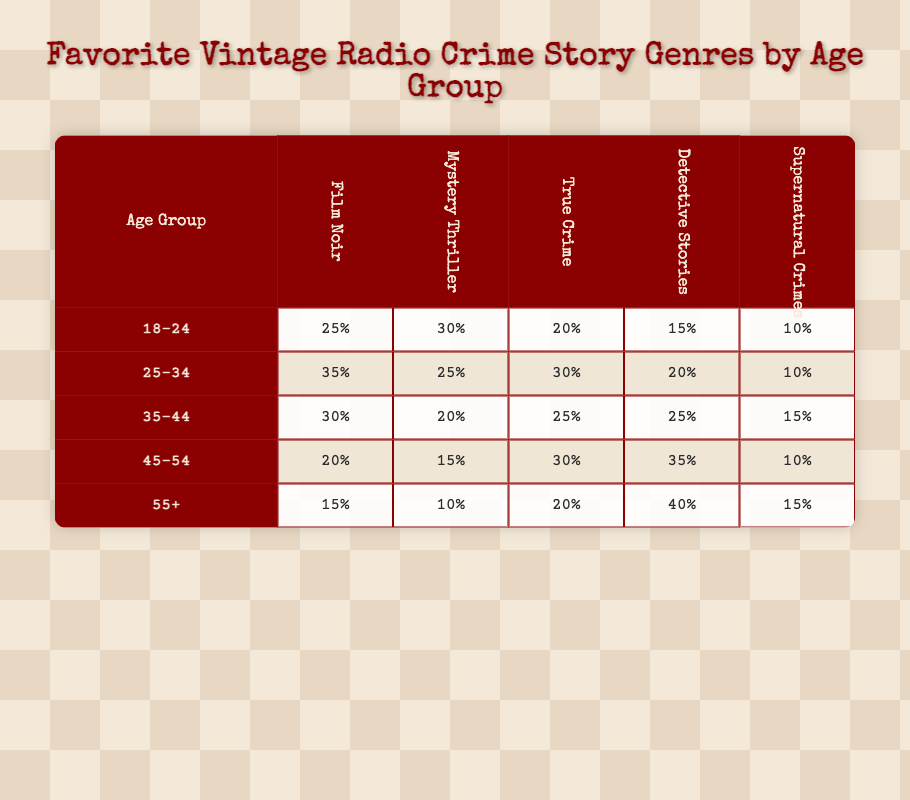What is the most popular genre among the 45-54 age group? In the 45-54 age group, the highest percentage is for Detective Stories, which has a value of 35%.
Answer: Detective Stories Which age group prefers Mystery Thriller the most? By inspecting the table, the highest value for Mystery Thriller appears in the 18-24 age group, with 30%.
Answer: 18-24 What percentage of the 25-34 age group prefers True Crime? The table shows that 30% of the 25-34 age group prefers True Crime.
Answer: 30% If we compare the Film Noir preferences of the 35-44 and 55+ age groups, which one has a higher percentage? The Film Noir preference for the 35-44 age group is 30%, while for the 55+ age group, it is 15%. Therefore, 35-44 has a higher percentage.
Answer: 35-44 What is the total percentage of people aged 18-24 who prefer either Film Noir or True Crime? The percentage for Film Noir among the 18-24 group is 25%, and for True Crime, it is 20%. Adding these together gives 25% + 20% = 45%.
Answer: 45% Is the Detective Stories genre preferred by more than 50% of any age group? Looking at the table, the highest preference for Detective Stories is 40% in the 55+ age group, which is not more than 50%.
Answer: No What is the average preference for Supernatural Crimes across all age groups? Adding the percentages for Supernatural Crimes: 10% (18-24) + 10% (25-34) + 15% (35-44) + 10% (45-54) + 15% (55+) = 60%. Dividing this by 5 age groups gives an average of 60% / 5 = 12%.
Answer: 12% 